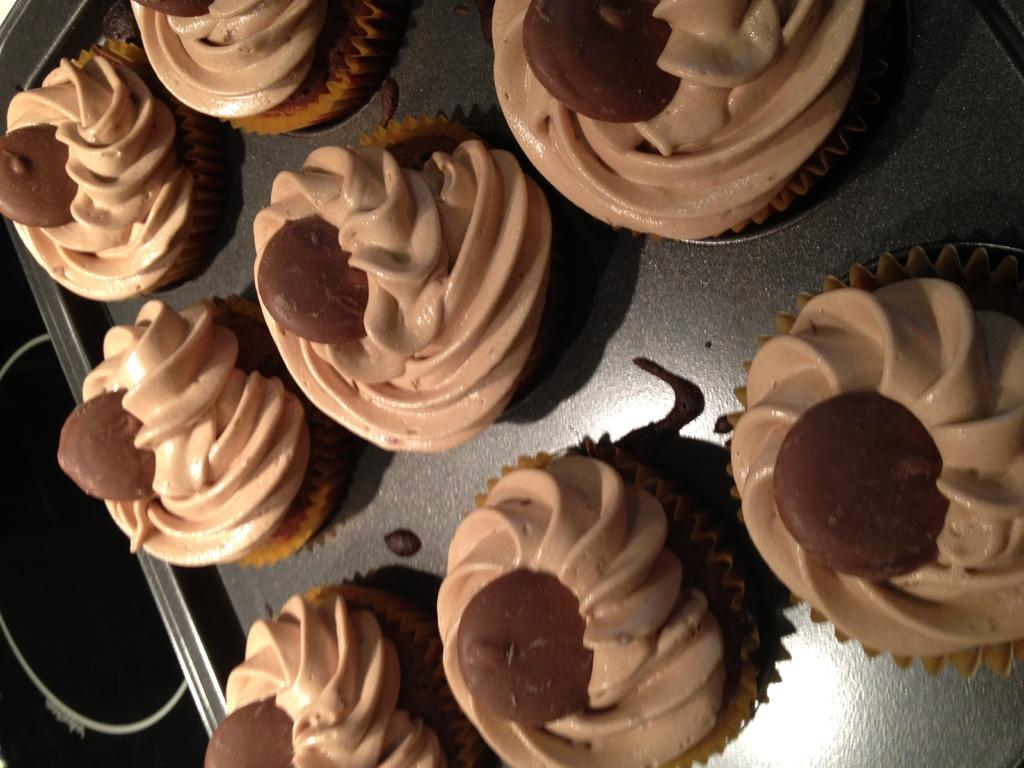What type of food is visible on the tray in the image? There are cupcakes on a tray in the image. Can you describe anything else visible in the image? There is an object visible in the background of the image. How many geese are visible in the field behind the cupcakes in the image? There are no geese or fields visible in the image; it only features cupcakes on a tray and an object in the background. 